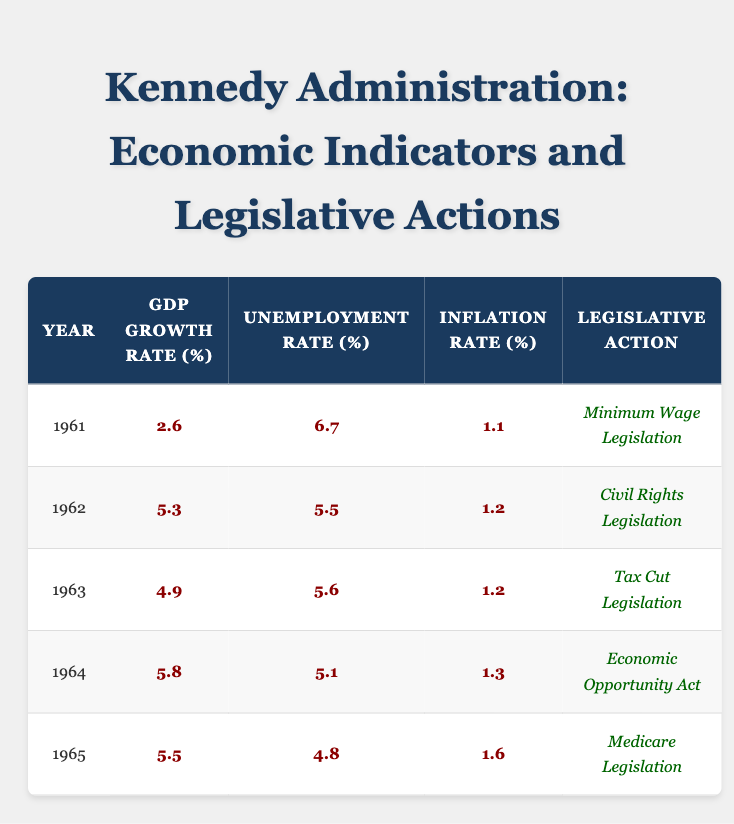What was the GDP growth rate in 1964? Looking at the table, the GDP growth rate for the year 1964 is provided under the corresponding column. It states that the GDP growth rate was 5.8%.
Answer: 5.8 In which year did the unemployment rate drop to its lowest point? By examining the unemployment rate data for each year in the table, I see that the lowest unemployment rate listed is 4.8%, which occurred in 1965.
Answer: 1965 What was the average inflation rate over the years 1961 to 1965? To find the average inflation rate, sum the inflation rates for each year: (1.1 + 1.2 + 1.2 + 1.3 + 1.6) = 6.4. Then divide by the number of years (5) to calculate the average: 6.4 / 5 = 1.28.
Answer: 1.28 Did the introduction of minimum wage legislation correlate with an increase in GDP growth rate? In the table, the year 1961 saw the introduction of minimum wage legislation with a GDP growth rate of 2.6%. The GDP growth rates in subsequent years were higher: 5.3% (1962), 4.9% (1963), and 5.8% (1964) with no legislation introduced. This suggests that minimum wage legislation did not correlate with increases in the GDP growth rate.
Answer: No What was the difference in GDP growth rate between 1963 and 1965? The GDP growth rate for 1963 is found to be 4.9%, and for 1965 it is 5.5%. To find the difference, subtract the 1963 value from the 1965 value: 5.5 - 4.9 = 0.6.
Answer: 0.6 Which legislative action corresponded with the highest GDP growth rate? By reviewing the table, the highest GDP growth rate listed is 5.8% in 1964, which corresponds with the Economic Opportunity Act.
Answer: Economic Opportunity Act Was the year with the highest GDP growth rate also the year with the lowest unemployment rate? The year with the highest GDP growth rate, 5.8%, occurred in 1964. The unemployment rate for that year was 5.1%, which is higher than the lowest unemployment rate of 4.8% observed in 1965. Thus, the two years correspond to different economic circumstances.
Answer: No What is the relationship between the inflation rate and the GDP growth rate from 1961 to 1965? Reviewing the data, during the years, as the GDP growth rate increased, the inflation rate fluctuated but generally showed an upward trend. For instance, the inflation rate increased from 1.1% in 1961 to 1.6% in 1965 despite a consistently positive GDP growth. This indicates that higher GDP growth did not necessarily mean lower inflation rates, implying a complex relationship between the two.
Answer: Fluctuating relationship 